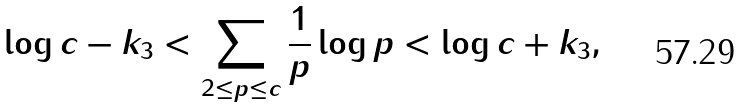<formula> <loc_0><loc_0><loc_500><loc_500>\log c - k _ { 3 } < \sum _ { 2 \leq p \leq c } { \frac { 1 } { p } } \log p < \log c + k _ { 3 } ,</formula> 